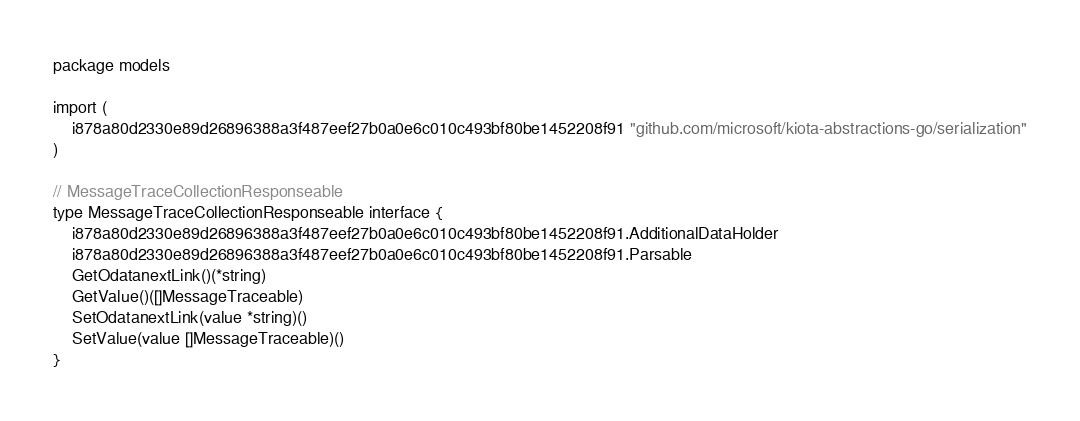Convert code to text. <code><loc_0><loc_0><loc_500><loc_500><_Go_>package models

import (
    i878a80d2330e89d26896388a3f487eef27b0a0e6c010c493bf80be1452208f91 "github.com/microsoft/kiota-abstractions-go/serialization"
)

// MessageTraceCollectionResponseable 
type MessageTraceCollectionResponseable interface {
    i878a80d2330e89d26896388a3f487eef27b0a0e6c010c493bf80be1452208f91.AdditionalDataHolder
    i878a80d2330e89d26896388a3f487eef27b0a0e6c010c493bf80be1452208f91.Parsable
    GetOdatanextLink()(*string)
    GetValue()([]MessageTraceable)
    SetOdatanextLink(value *string)()
    SetValue(value []MessageTraceable)()
}
</code> 